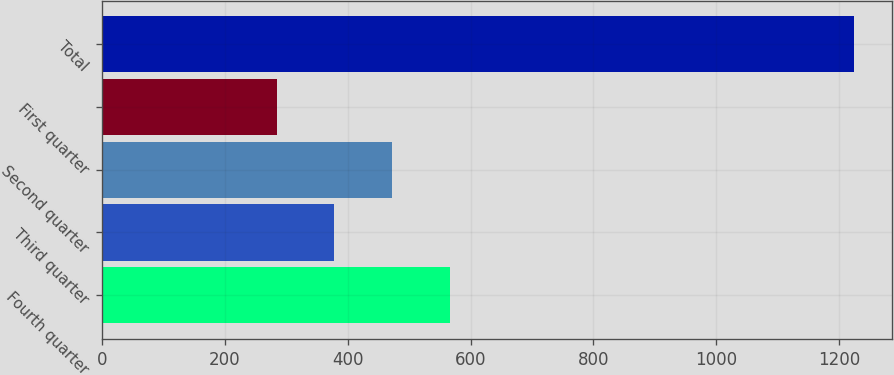Convert chart. <chart><loc_0><loc_0><loc_500><loc_500><bar_chart><fcel>Fourth quarter<fcel>Third quarter<fcel>Second quarter<fcel>First quarter<fcel>Total<nl><fcel>566.3<fcel>378.1<fcel>472.2<fcel>284<fcel>1225<nl></chart> 